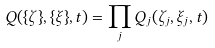<formula> <loc_0><loc_0><loc_500><loc_500>Q ( \{ \zeta \} , \{ \xi \} , t ) = \prod _ { j } Q _ { j } ( \zeta _ { j } , \xi _ { j } , t )</formula> 